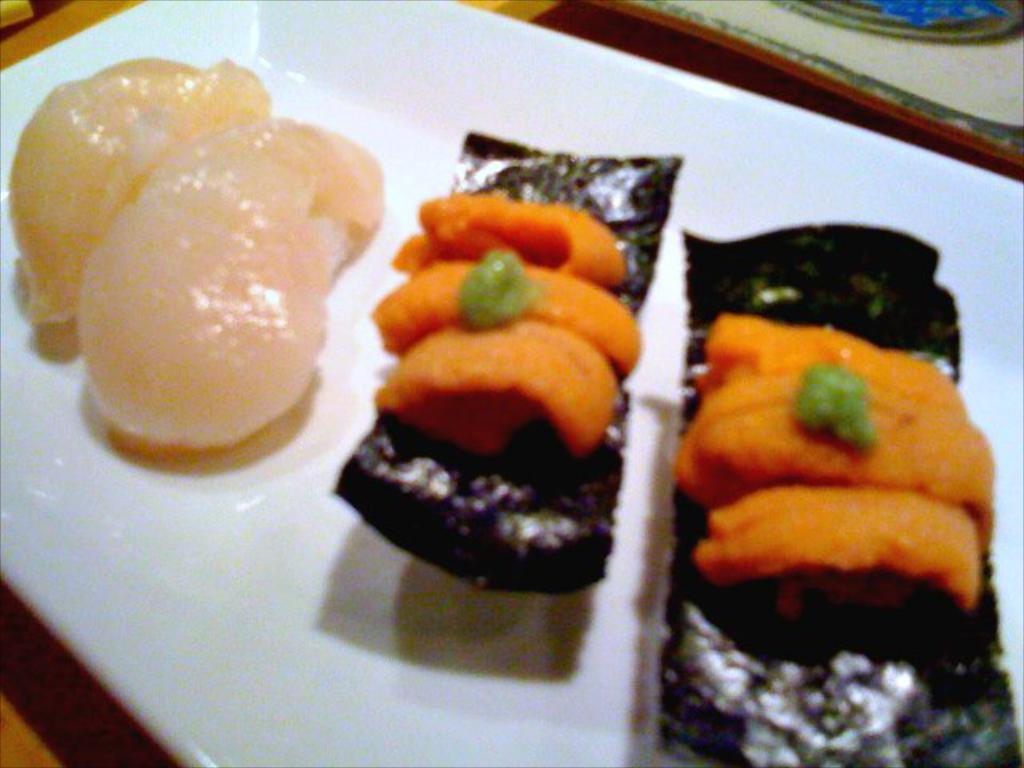What is on the plate in the image? There are food items on a white plate in the image. What is the plate resting on? The plate is on a wooden object. What is present on the right side of the plate? There is a table mat on the right side of the plate in the image. How many noses can be seen teaching on the table in the image? There are no noses or teaching activities depicted in the image; it features a plate with food items on a wooden object with a table mat on the right side. 